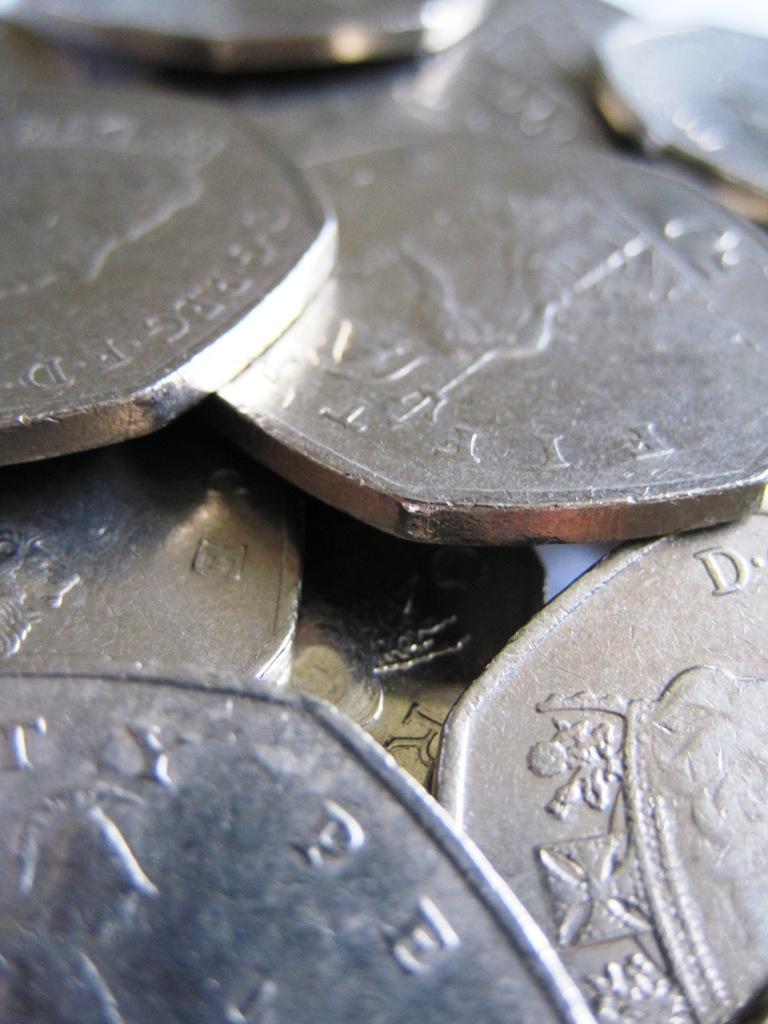How would you summarize this image in a sentence or two? In this image I can see few coins. 